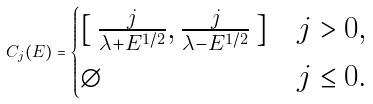<formula> <loc_0><loc_0><loc_500><loc_500>C _ { j } ( E ) = \begin{cases} [ \, \frac { j } { \lambda + E ^ { 1 / 2 } } , \frac { j } { \lambda - E ^ { 1 / 2 } } \, ] & j > 0 , \\ \emptyset & j \leq 0 . \\ \end{cases}</formula> 